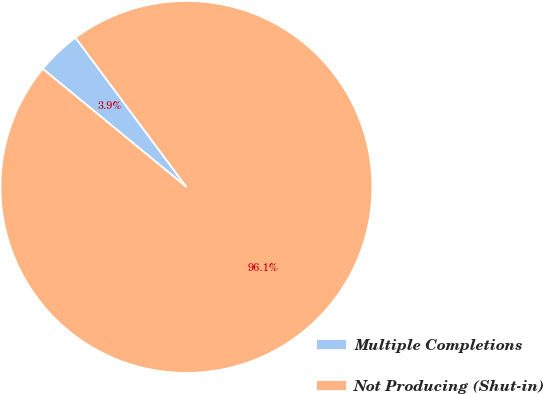<chart> <loc_0><loc_0><loc_500><loc_500><pie_chart><fcel>Multiple Completions<fcel>Not Producing (Shut-in)<nl><fcel>3.88%<fcel>96.12%<nl></chart> 